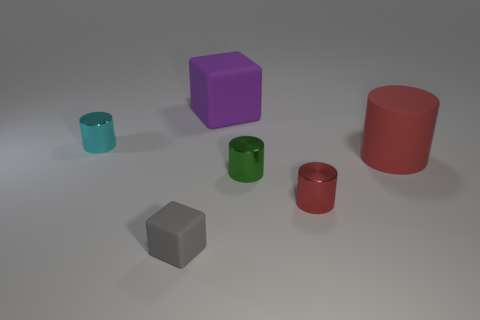Subtract all tiny green cylinders. How many cylinders are left? 3 Subtract all cyan cubes. How many red cylinders are left? 2 Add 4 purple rubber cubes. How many objects exist? 10 Subtract 3 cylinders. How many cylinders are left? 1 Subtract all cyan cylinders. How many cylinders are left? 3 Subtract all cylinders. How many objects are left? 2 Subtract all red cylinders. Subtract all cyan balls. How many cylinders are left? 2 Subtract all small matte cubes. Subtract all red objects. How many objects are left? 3 Add 4 tiny cylinders. How many tiny cylinders are left? 7 Add 6 big red rubber balls. How many big red rubber balls exist? 6 